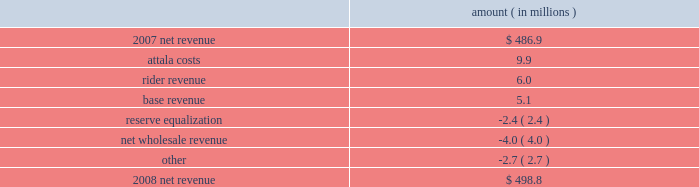Entergy mississippi , inc .
Management's financial discussion and analysis results of operations net income 2008 compared to 2007 net income decreased $ 12.4 million primarily due to higher other operation and maintenance expenses , lower other income , and higher depreciation and amortization expenses , partially offset by higher net revenue .
2007 compared to 2006 net income increased $ 19.8 million primarily due to higher net revenue , lower other operation and maintenance expenses , higher other income , and lower interest expense , partially offset by higher depreciation and amortization expenses .
Net revenue 2008 compared to 2007 net revenue consists of operating revenues net of : 1 ) fuel , fuel-related expenses , and gas purchased for resale , 2 ) purchased power expenses , and 3 ) other regulatory charges .
Following is an analysis of the change in net revenue comparing 2008 to 2007 .
Amount ( in millions ) .
The attala costs variance is primarily due to an increase in the attala power plant costs that are recovered through the power management rider .
The net income effect of this recovery in limited to a portion representing an allowed return on equity with the remainder offset by attala power plant costs in other operation and maintenance expenses , depreciation expenses , and taxes other than income taxes .
The recovery of attala power plant costs is discussed further in "liquidity and capital resources - uses of capital" below .
The rider revenue variance is the result of a storm damage rider that became effective in october 2007 .
The establishment of this rider results in an increase in rider revenue and a corresponding increase in other operation and maintenance expense for the storm reserve with no effect on net income .
The base revenue variance is primarily due to a formula rate plan increase effective july 2007 .
The formula rate plan filing is discussed further in "state and local rate regulation" below .
The reserve equalization variance is primarily due to changes in the entergy system generation mix compared to the same period in 2007. .
What is the growth rate in net revenue during 2008? 
Computations: ((498.8 - 486.9) / 486.9)
Answer: 0.02444. 